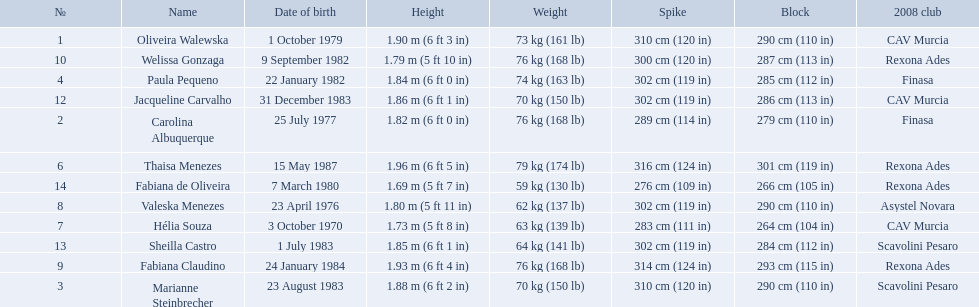What are the names of all the contestants? Oliveira Walewska, Carolina Albuquerque, Marianne Steinbrecher, Paula Pequeno, Thaisa Menezes, Hélia Souza, Valeska Menezes, Fabiana Claudino, Welissa Gonzaga, Jacqueline Carvalho, Sheilla Castro, Fabiana de Oliveira. What are the weight ranges of the contestants? 73 kg (161 lb), 76 kg (168 lb), 70 kg (150 lb), 74 kg (163 lb), 79 kg (174 lb), 63 kg (139 lb), 62 kg (137 lb), 76 kg (168 lb), 76 kg (168 lb), 70 kg (150 lb), 64 kg (141 lb), 59 kg (130 lb). Which player is heaviest. sheilla castro, fabiana de oliveira, or helia souza? Sheilla Castro. What are the heights of the players? 1.90 m (6 ft 3 in), 1.82 m (6 ft 0 in), 1.88 m (6 ft 2 in), 1.84 m (6 ft 0 in), 1.96 m (6 ft 5 in), 1.73 m (5 ft 8 in), 1.80 m (5 ft 11 in), 1.93 m (6 ft 4 in), 1.79 m (5 ft 10 in), 1.86 m (6 ft 1 in), 1.85 m (6 ft 1 in), 1.69 m (5 ft 7 in). Which of these heights is the shortest? 1.69 m (5 ft 7 in). Which player is 5'7 tall? Fabiana de Oliveira. 